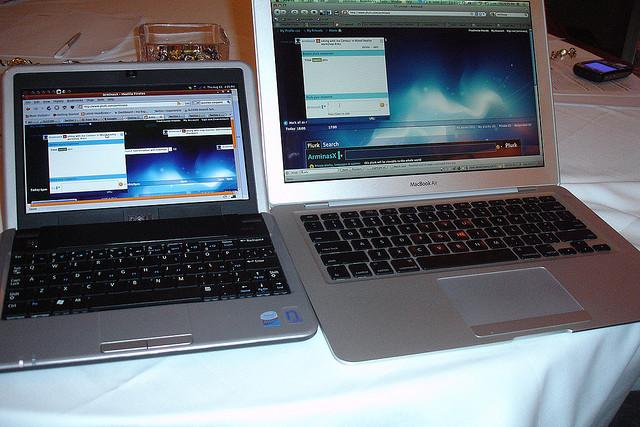What is side by side? Please explain your reasoning. laptops. The other options don't appear on the table. it looks like the screens are synced as well. 